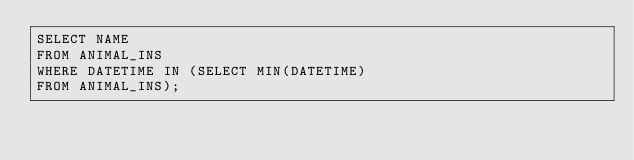<code> <loc_0><loc_0><loc_500><loc_500><_SQL_>SELECT NAME
FROM ANIMAL_INS
WHERE DATETIME IN (SELECT MIN(DATETIME)
FROM ANIMAL_INS);</code> 